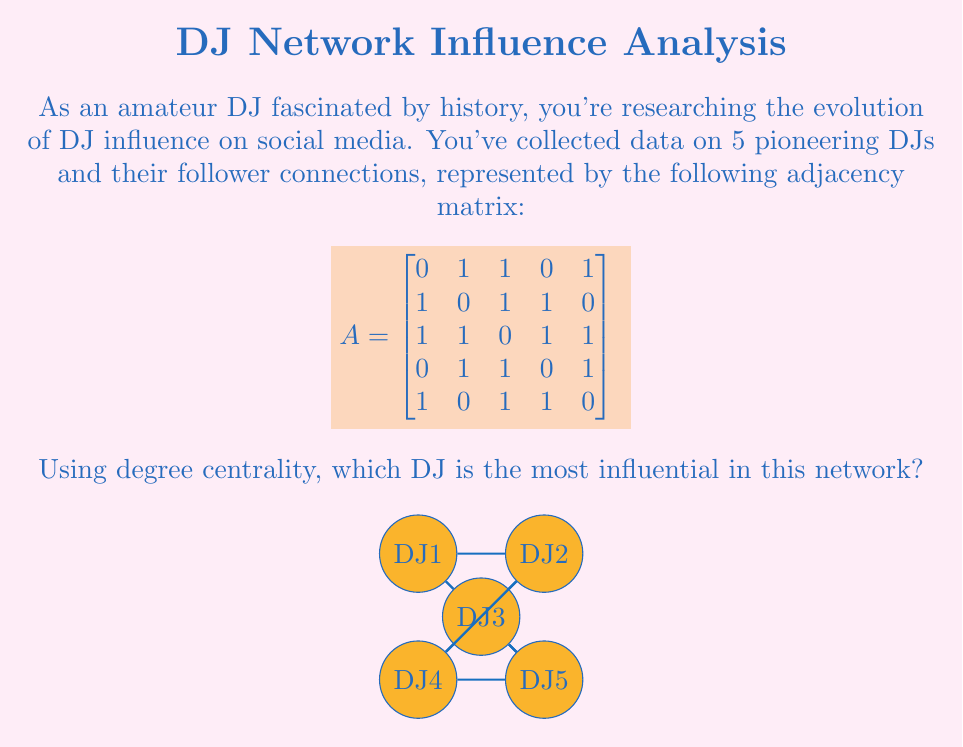Give your solution to this math problem. To solve this problem, we need to calculate the degree centrality for each DJ in the network. Degree centrality is a measure of the number of direct connections a node has in a network.

Step 1: Calculate the degree of each DJ
The degree of a node in an undirected graph is the number of edges connected to it. In the adjacency matrix, this is equal to the sum of the row (or column) corresponding to that node.

DJ1: $1 + 1 + 0 + 1 = 3$
DJ2: $1 + 1 + 1 + 0 = 3$
DJ3: $1 + 1 + 1 + 1 = 4$
DJ4: $0 + 1 + 1 + 1 = 3$
DJ5: $1 + 0 + 1 + 1 = 3$

Step 2: Identify the highest degree
The highest degree is 4, corresponding to DJ3.

Step 3: Interpret the result
In this network, DJ3 has the highest degree centrality, meaning they have the most direct connections to other DJs. This suggests that DJ3 is the most influential in terms of reach and potential information spread within this network.

Historical context: This analysis method can be related to how influential DJs in history built networks and connections, which contributed to their impact on the music scene.
Answer: DJ3 